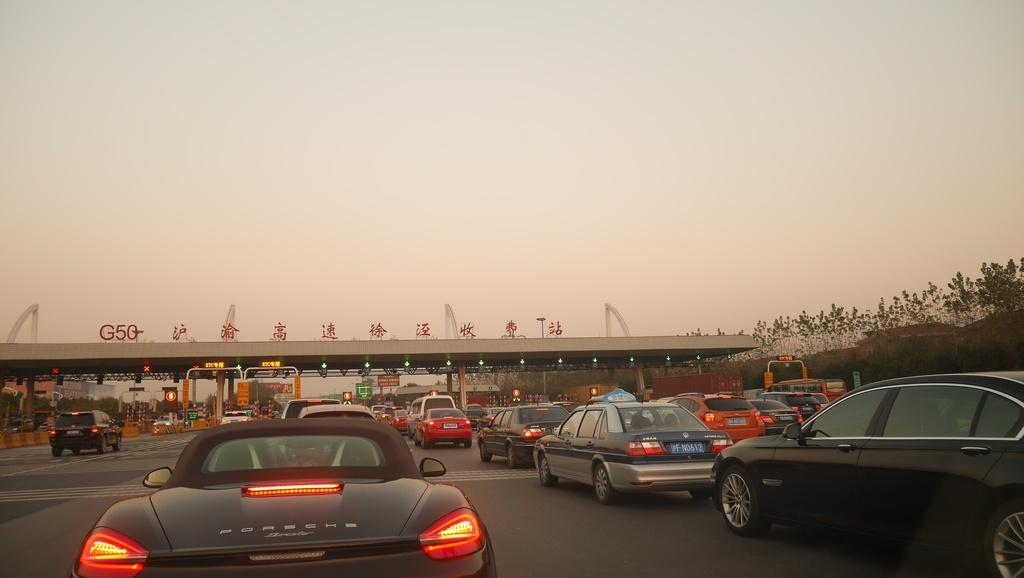What can be seen on the road in the image? There are vehicles on the road in the image. What is located in the background of the image? There is a toll plaza, trees, and buildings visible in the background of the image. What is visible at the top of the image? The sky is visible at the top of the image. What type of meal is being served at the toll plaza in the image? There is no meal being served at the toll plaza in the image; it is a structure for collecting tolls from vehicles. What type of rail can be seen in the image? There is no rail present in the image; it features a road with vehicles and a toll plaza. 